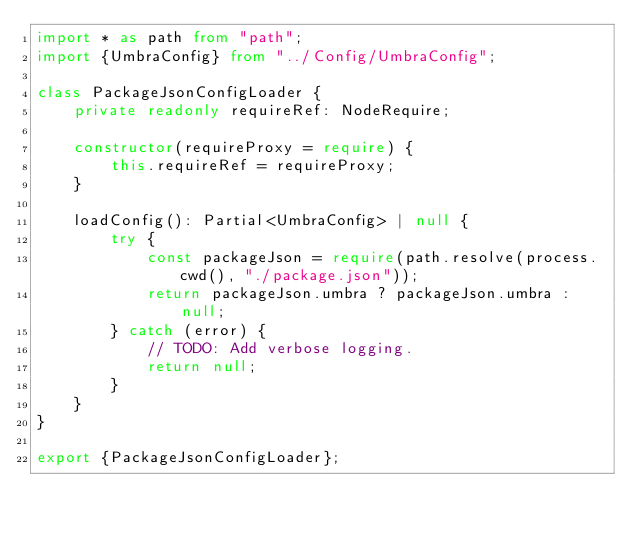<code> <loc_0><loc_0><loc_500><loc_500><_TypeScript_>import * as path from "path";
import {UmbraConfig} from "../Config/UmbraConfig";

class PackageJsonConfigLoader {
    private readonly requireRef: NodeRequire;

    constructor(requireProxy = require) {
        this.requireRef = requireProxy;
    }

    loadConfig(): Partial<UmbraConfig> | null {
        try {
            const packageJson = require(path.resolve(process.cwd(), "./package.json"));
            return packageJson.umbra ? packageJson.umbra : null;
        } catch (error) {
            // TODO: Add verbose logging.
            return null;
        }
    }
}

export {PackageJsonConfigLoader};
</code> 